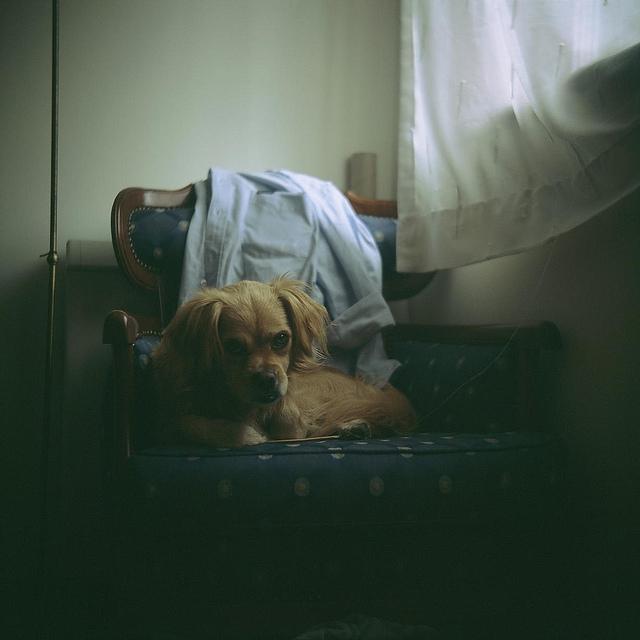Is the dog looking at someone?
Concise answer only. Yes. Is the dog a puppy?
Be succinct. Yes. Where is the dog?
Quick response, please. Chair. Is the dog sleeping?
Quick response, please. No. What colors are the pillow behind the dog?
Short answer required. Blue. What color is the curtain?
Be succinct. White. What type of dog is this?
Concise answer only. Spaniel. What is the puppy lying in?
Concise answer only. Chair. What color is the fur on the dog?
Answer briefly. Brown. Where is the dog looking?
Be succinct. At camera. Does this dog look tired?
Concise answer only. Yes. What breed of dog is this?
Be succinct. Terrier. What color is most of the dogs hair?
Quick response, please. Brown. Is the dog's coat brindle in color?
Short answer required. Yes. Is the dog laying on its back?
Be succinct. No. What color is the rocking chair?
Answer briefly. Blue. What is the dog inside of?
Write a very short answer. Chair. What is the dog doing?
Be succinct. Sitting. What kind of dog is this?
Short answer required. Spaniel. Do this dog's owners pamper it?
Short answer required. Yes. 